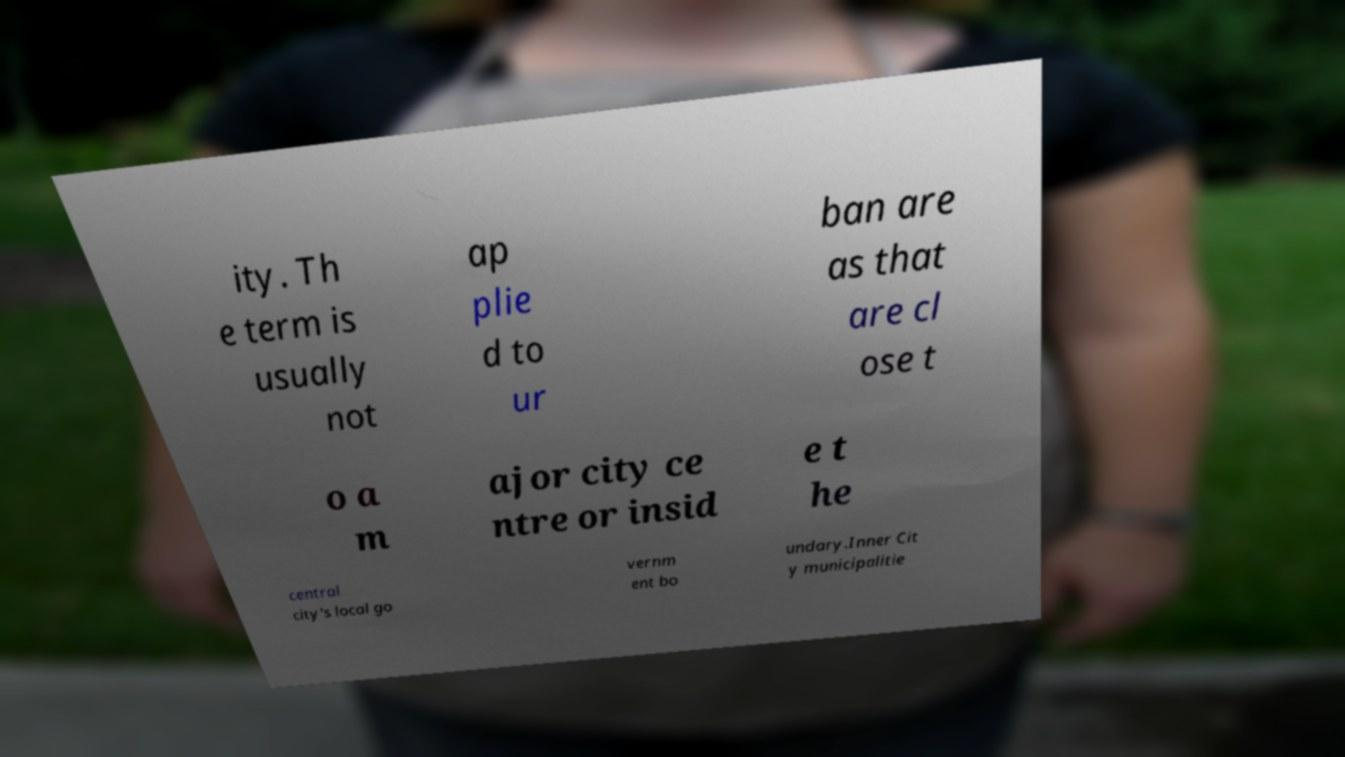Could you extract and type out the text from this image? ity. Th e term is usually not ap plie d to ur ban are as that are cl ose t o a m ajor city ce ntre or insid e t he central city's local go vernm ent bo undary.Inner Cit y municipalitie 